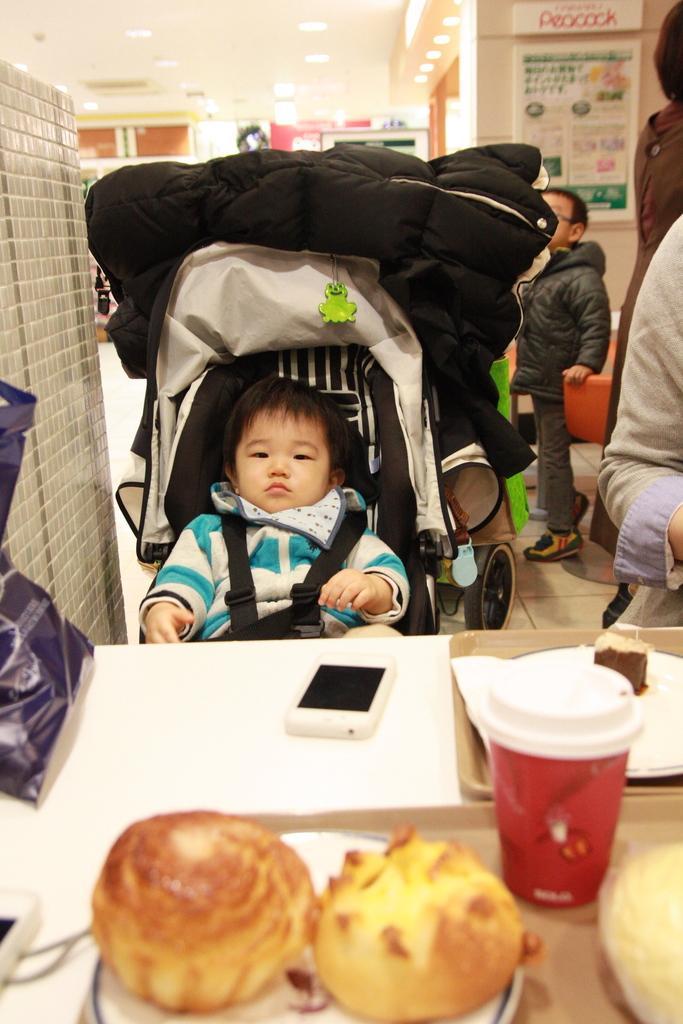Can you describe this image briefly? In this image we can see a boy sitting in the stroller, in front of him we can see a table, on the table, we can see some food, mobile phone and some other objects, at the top we can see some lights, and on the wall there is a poster with some text and images, also we can see some persons standing on the floor. 